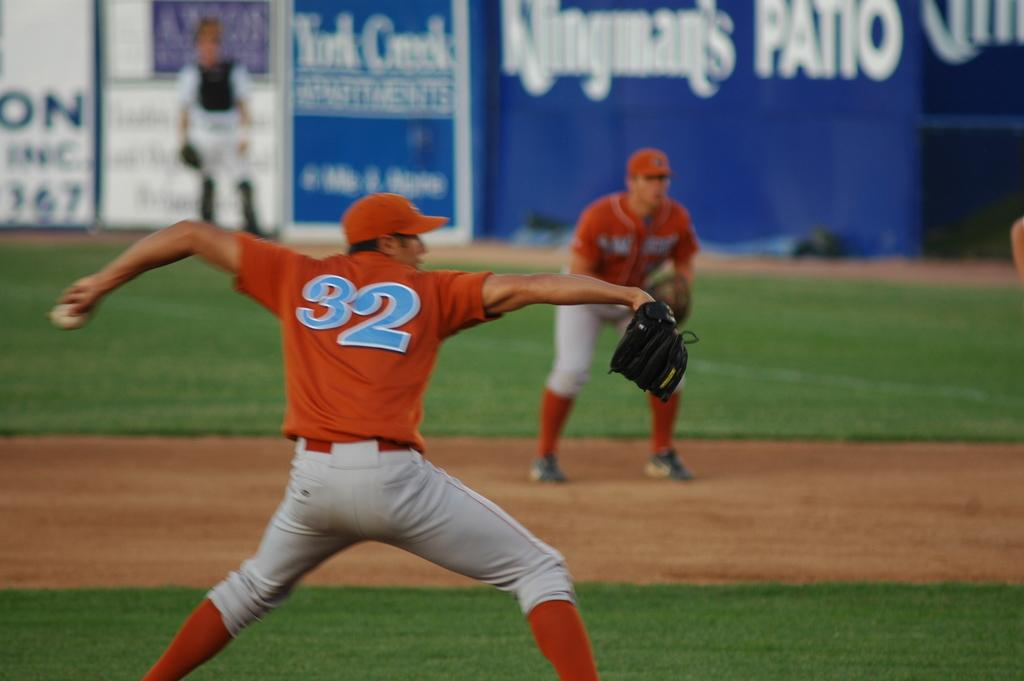Provide a one-sentence caption for the provided image. A sports man in a number 32 shirt throwing a ball. 